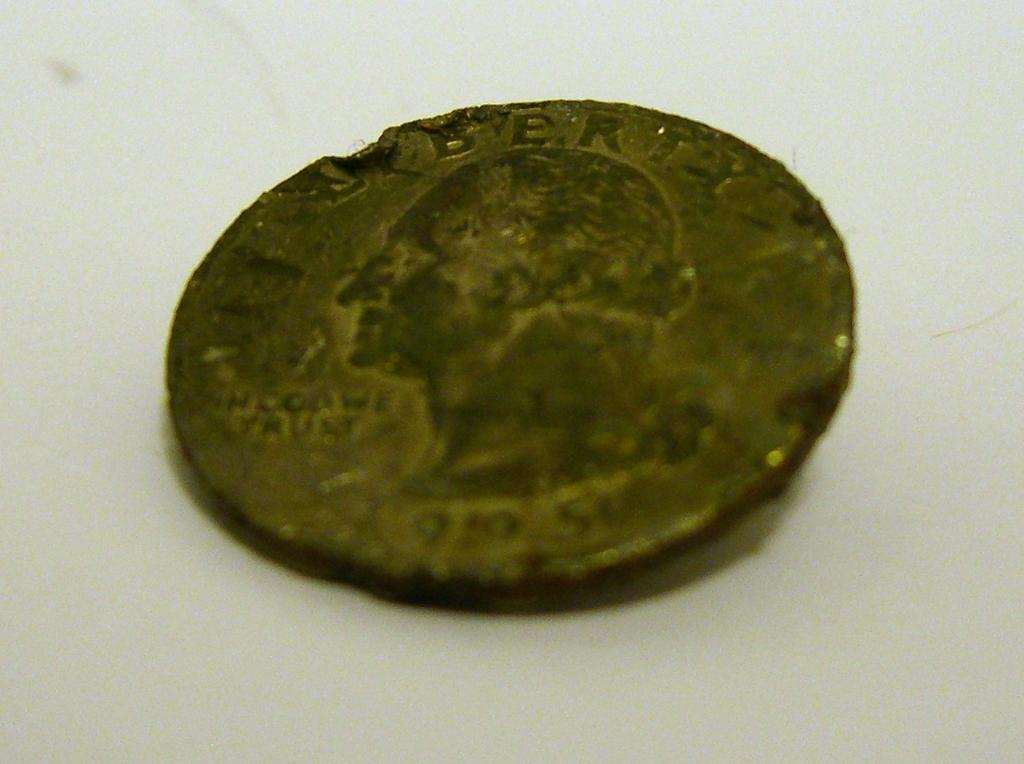<image>
Offer a succinct explanation of the picture presented. A very damaged and old coin has the year 1905 on the front of the coin. 